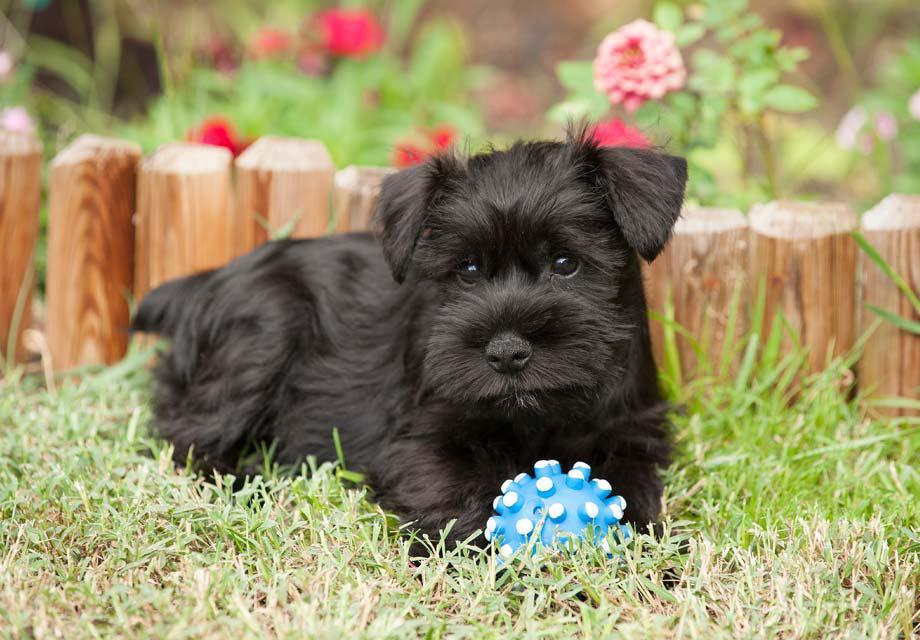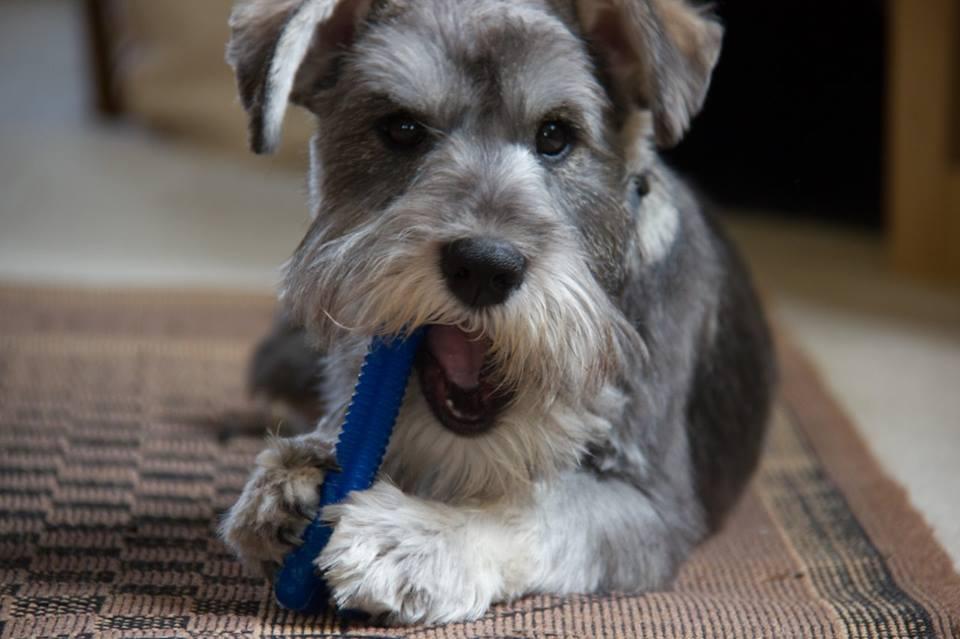The first image is the image on the left, the second image is the image on the right. Assess this claim about the two images: "A dog is chewing on something in one of the photos.". Correct or not? Answer yes or no. Yes. The first image is the image on the left, the second image is the image on the right. For the images shown, is this caption "In one of the images there is a dog chewing a dog bone." true? Answer yes or no. Yes. 